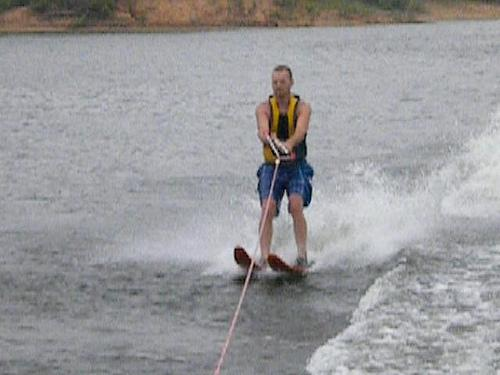Question: what is the yellow thing the man is wearing?
Choices:
A. Jacket.
B. Sweater.
C. Shorts.
D. Life vest.
Answer with the letter. Answer: D Question: what color shorts is the man wearing?
Choices:
A. Black.
B. Blue.
C. Green.
D. Tan.
Answer with the letter. Answer: B Question: what are the man's feet attached to?
Choices:
A. Roller skates.
B. Stilts.
C. Water skis.
D. His shoes.
Answer with the letter. Answer: C 